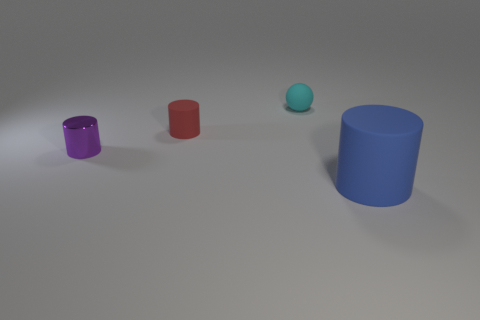Are there any other things that are the same shape as the cyan thing?
Offer a very short reply. No. Is the shape of the purple shiny thing the same as the cyan rubber thing?
Give a very brief answer. No. Are there the same number of purple cylinders behind the tiny red cylinder and objects right of the ball?
Give a very brief answer. No. There is a rubber cylinder on the right side of the tiny red thing; is there a tiny ball right of it?
Offer a very short reply. No. There is a object that is both in front of the red object and on the right side of the purple thing; how big is it?
Your answer should be compact. Large. There is another big object that is the same material as the cyan object; what is its shape?
Offer a very short reply. Cylinder. What shape is the purple object?
Make the answer very short. Cylinder. There is a cylinder that is in front of the red rubber cylinder and behind the blue cylinder; what color is it?
Provide a succinct answer. Purple. The cyan object that is the same size as the purple thing is what shape?
Offer a terse response. Sphere. Is there a tiny metal thing of the same shape as the big object?
Make the answer very short. Yes. 